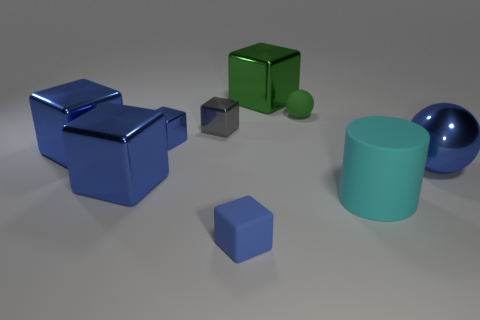There is a thing that is the same color as the small matte sphere; what shape is it?
Provide a short and direct response. Cube. What number of big metal things are the same color as the rubber ball?
Your answer should be very brief. 1. What number of other objects are the same material as the large cyan cylinder?
Make the answer very short. 2. Is the shape of the small rubber thing in front of the gray cube the same as  the cyan rubber object?
Give a very brief answer. No. Is there a small red metal thing?
Ensure brevity in your answer.  No. Is there any other thing that has the same shape as the big cyan matte thing?
Provide a succinct answer. No. Is the number of balls to the left of the cyan object greater than the number of big brown metal spheres?
Provide a short and direct response. Yes. Are there any spheres on the left side of the small sphere?
Keep it short and to the point. No. Do the blue sphere and the green metal block have the same size?
Offer a very short reply. Yes. There is a gray metallic object that is the same shape as the tiny blue matte thing; what size is it?
Provide a short and direct response. Small. 